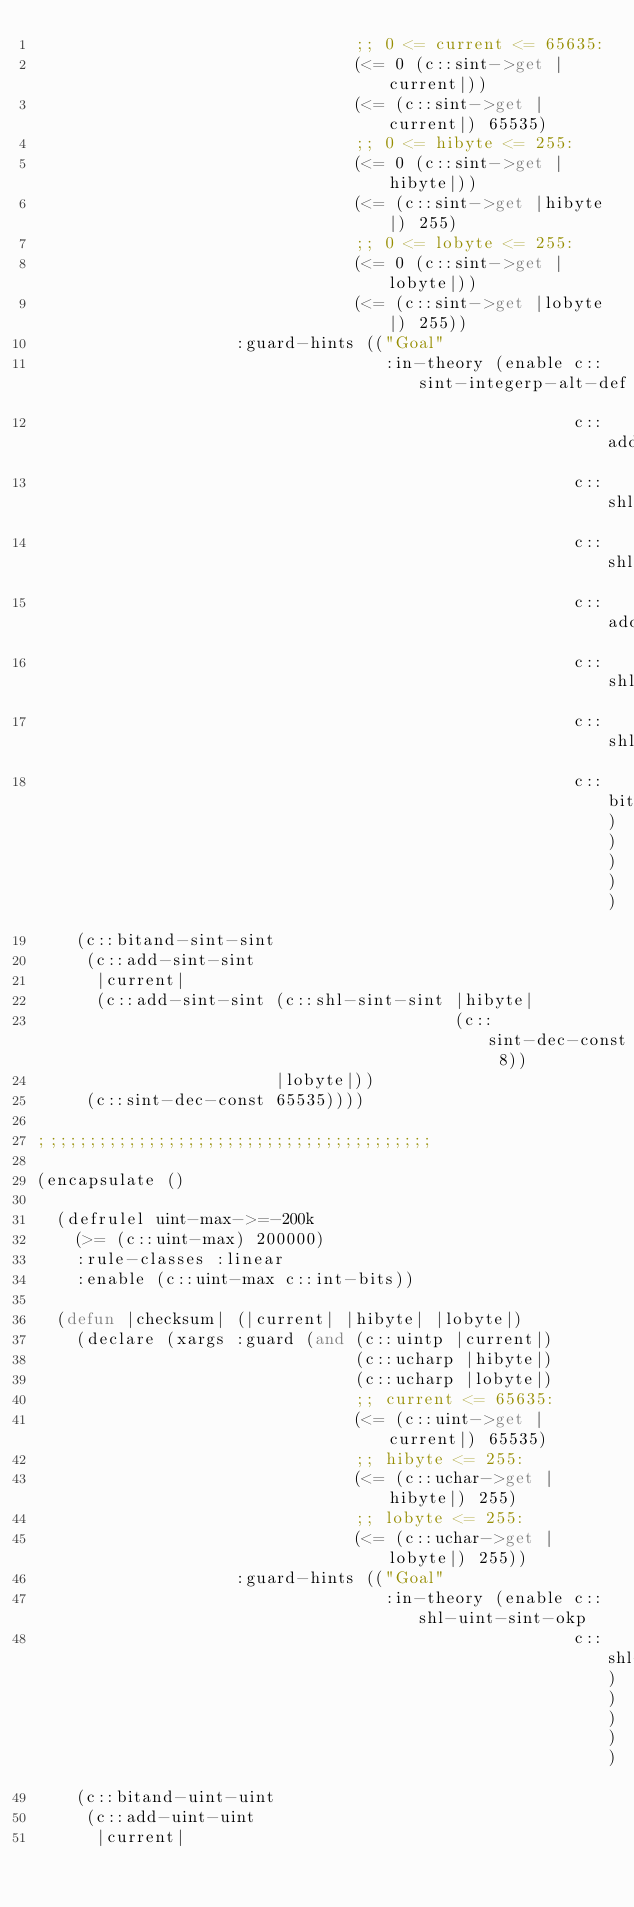<code> <loc_0><loc_0><loc_500><loc_500><_Lisp_>                                ;; 0 <= current <= 65635:
                                (<= 0 (c::sint->get |current|))
                                (<= (c::sint->get |current|) 65535)
                                ;; 0 <= hibyte <= 255:
                                (<= 0 (c::sint->get |hibyte|))
                                (<= (c::sint->get |hibyte|) 255)
                                ;; 0 <= lobyte <= 255:
                                (<= 0 (c::sint->get |lobyte|))
                                (<= (c::sint->get |lobyte|) 255))
                    :guard-hints (("Goal"
                                   :in-theory (enable c::sint-integerp-alt-def
                                                      c::add-sint-sint-okp
                                                      c::shl-sint-sint-okp
                                                      c::shl-sint-okp
                                                      c::add-sint-sint
                                                      c::shl-sint-sint
                                                      c::shl-sint
                                                      c::bitand-sint-sint)))))
    (c::bitand-sint-sint
     (c::add-sint-sint
      |current|
      (c::add-sint-sint (c::shl-sint-sint |hibyte|
                                          (c::sint-dec-const 8))
                        |lobyte|))
     (c::sint-dec-const 65535))))

;;;;;;;;;;;;;;;;;;;;;;;;;;;;;;;;;;;;;;;;

(encapsulate ()

  (defrulel uint-max->=-200k
    (>= (c::uint-max) 200000)
    :rule-classes :linear
    :enable (c::uint-max c::int-bits))

  (defun |checksum| (|current| |hibyte| |lobyte|)
    (declare (xargs :guard (and (c::uintp |current|)
                                (c::ucharp |hibyte|)
                                (c::ucharp |lobyte|)
                                ;; current <= 65635:
                                (<= (c::uint->get |current|) 65535)
                                ;; hibyte <= 255:
                                (<= (c::uchar->get |hibyte|) 255)
                                ;; lobyte <= 255:
                                (<= (c::uchar->get |lobyte|) 255))
                    :guard-hints (("Goal"
                                   :in-theory (enable c::shl-uint-sint-okp
                                                      c::shl-uint-okp)))))
    (c::bitand-uint-uint
     (c::add-uint-uint
      |current|</code> 